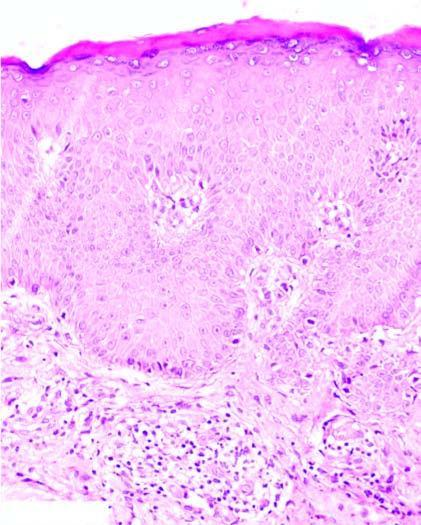does the epidermis show hyperkeratosis, acathosis and broadened papillae and spongiosis of the epidermal layers?
Answer the question using a single word or phrase. Yes 